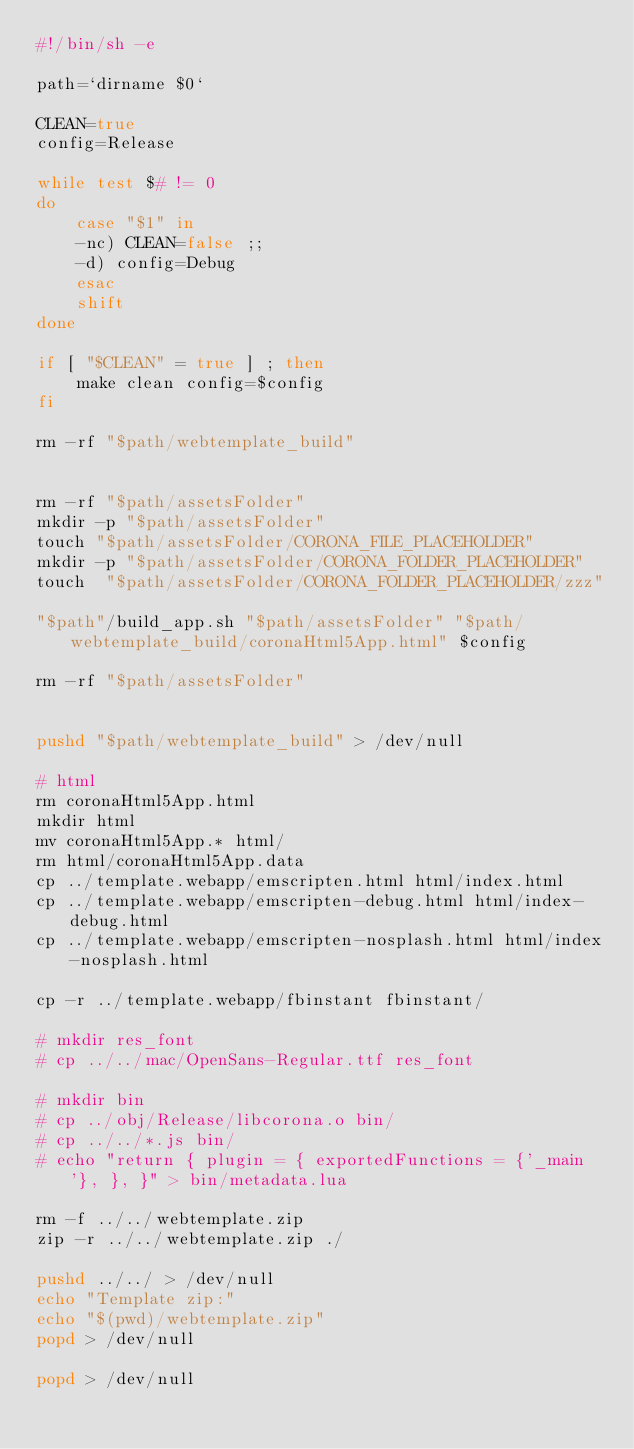<code> <loc_0><loc_0><loc_500><loc_500><_Bash_>#!/bin/sh -e

path=`dirname $0`

CLEAN=true
config=Release

while test $# != 0
do
    case "$1" in
    -nc) CLEAN=false ;;
	-d) config=Debug
    esac
    shift
done

if [ "$CLEAN" = true ] ; then
    make clean config=$config
fi

rm -rf "$path/webtemplate_build"


rm -rf "$path/assetsFolder"
mkdir -p "$path/assetsFolder"
touch "$path/assetsFolder/CORONA_FILE_PLACEHOLDER"
mkdir -p "$path/assetsFolder/CORONA_FOLDER_PLACEHOLDER"
touch  "$path/assetsFolder/CORONA_FOLDER_PLACEHOLDER/zzz"

"$path"/build_app.sh "$path/assetsFolder" "$path/webtemplate_build/coronaHtml5App.html" $config

rm -rf "$path/assetsFolder"


pushd "$path/webtemplate_build" > /dev/null

# html
rm coronaHtml5App.html
mkdir html
mv coronaHtml5App.* html/
rm html/coronaHtml5App.data
cp ../template.webapp/emscripten.html html/index.html
cp ../template.webapp/emscripten-debug.html html/index-debug.html
cp ../template.webapp/emscripten-nosplash.html html/index-nosplash.html

cp -r ../template.webapp/fbinstant fbinstant/

# mkdir res_font
# cp ../../mac/OpenSans-Regular.ttf res_font

# mkdir bin
# cp ../obj/Release/libcorona.o bin/
# cp ../../*.js bin/
# echo "return { plugin = { exportedFunctions = {'_main'}, }, }" > bin/metadata.lua

rm -f ../../webtemplate.zip
zip -r ../../webtemplate.zip ./

pushd ../../ > /dev/null
echo "Template zip:"
echo "$(pwd)/webtemplate.zip"
popd > /dev/null

popd > /dev/null</code> 